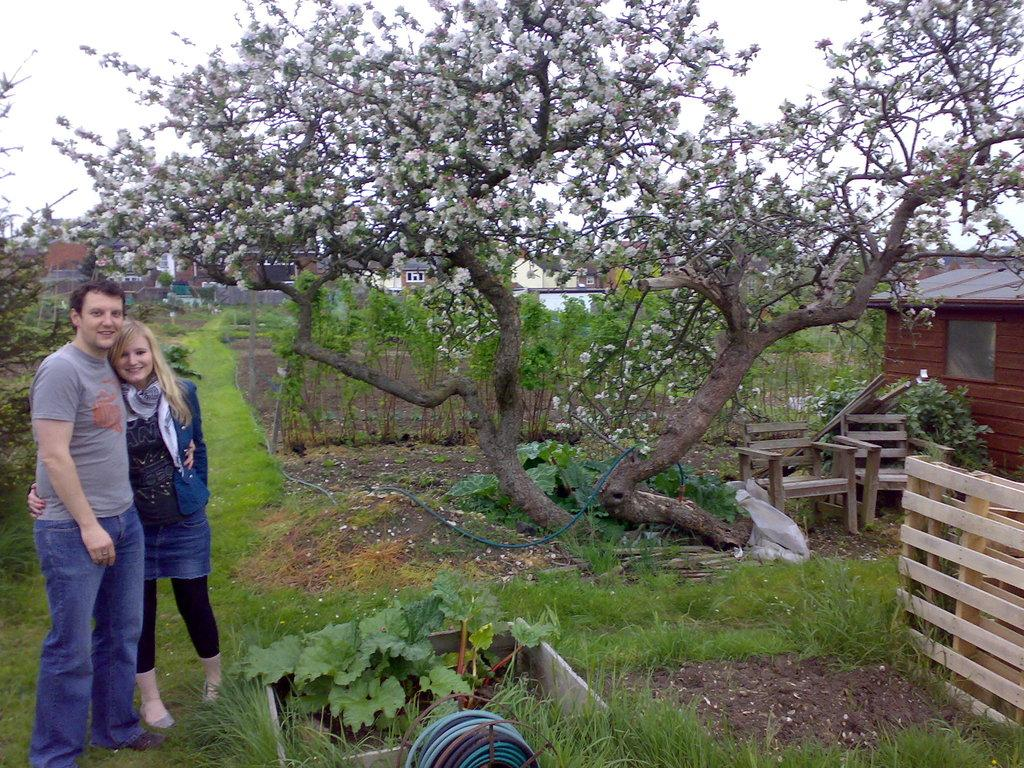Who is present in the image? There is a couple in the image. Where are the couple located in the image? The couple is on the left side of the image. What is the emotional expression of the couple? Both individuals in the couple are smiling. What can be seen in the middle of the image? There is a tree in the middle of the image. What is visible in the background of the image? The sky is visible in the background of the image. What type of flowers are growing on the couple's skin in the image? There are no flowers visible on the couple's skin in the image. What is the color of the brain that can be seen in the image? There is no brain present in the image. 